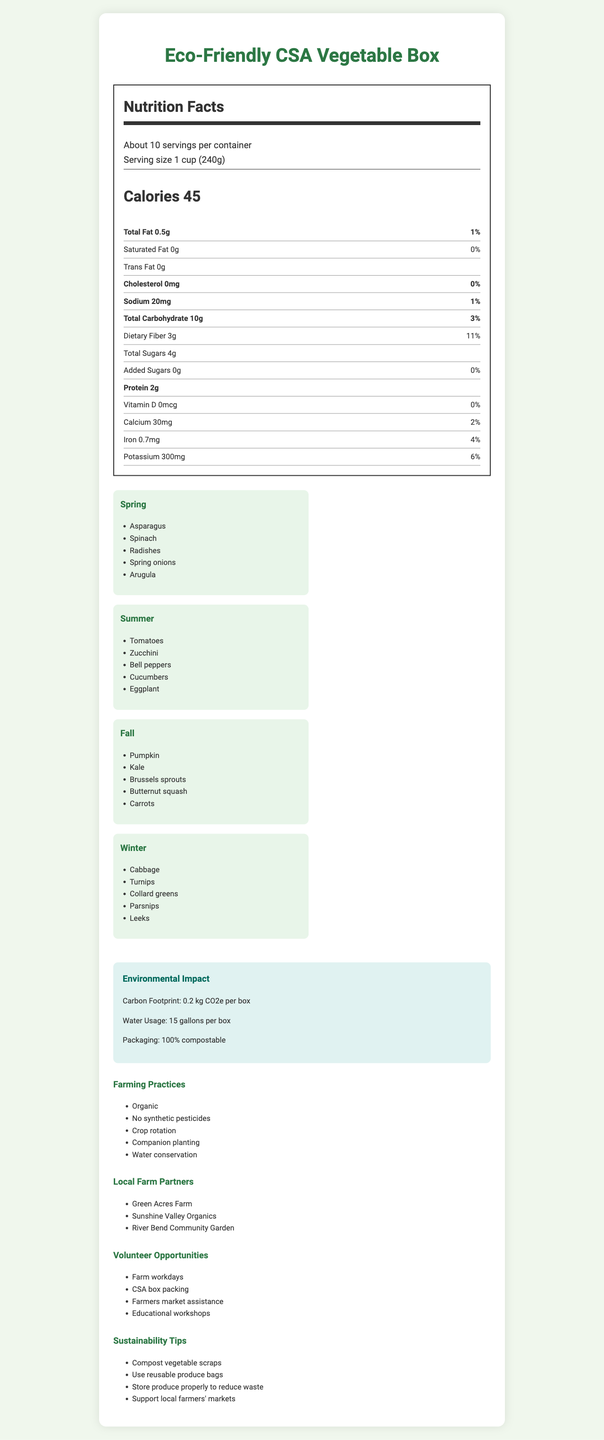what is the serving size? The document specifies the serving size as "1 cup (240g)" near the top of the Nutrition Facts label.
Answer: 1 cup (240g) how many calories are there per serving? The Nutrition Facts section clearly states "Calories 45".
Answer: 45 calories what are the total carbohydrates per serving? The Nutrition Facts section lists "Total Carbohydrate 10g".
Answer: 10g how much protein is in each serving? The Nutrition Facts label states there are "Protein 2g" per serving.
Answer: 2g what seasonal vegetables are included in the winter breakdown? The Winter breakdown lists these vegetables: Cabbage, Turnips, Collard greens, Parsnips, Leeks.
Answer: Cabbage, Turnips, Collard greens, Parsnips, Leeks which farming practice is mentioned first? Under the "Farming Practices" section, the first practice listed is "Organic".
Answer: Organic what is the carbon footprint of each box? A. 0.5 kg CO2e B. 0.2 kg CO2e C. 1 kg CO2e The "Environmental Impact" section indicates the carbon footprint as "0.2 kg CO2e per box".
Answer: B. 0.2 kg CO2e how much calcium is in a serving? A. 2mg B. 30mg C. 50mg D. 70mg The Nutrition Facts section shows "Calcium 30mg".
Answer: B. 30mg does this product contain any trans fat? The Nutrition Facts label shows "Trans Fat 0g", indicating there is no trans fat in the product.
Answer: No is the packaging compostable? The "Environmental Impact" section mentions that the packaging is "100% compostable".
Answer: Yes summarize the main content of the document This document is designed to give a comprehensive overview of the "Eco-Friendly CSA Vegetable Box," covering nutritional details, environmental footprint, and additional information related to farming and sustainability.
Answer: The document provides detailed Nutrition Facts for the "Eco-Friendly CSA Vegetable Box," including calories, fat, sodium, carbohydrates, and other nutrients. It also lists the seasonal produce breakdown, environmental impact, farming practices, local farm partners, volunteer opportunities, and sustainability tips. what is the address of Green Acres Farm? The document mentions "Green Acres Farm" as a local farm partner but does not provide its address.
Answer: Not enough information 